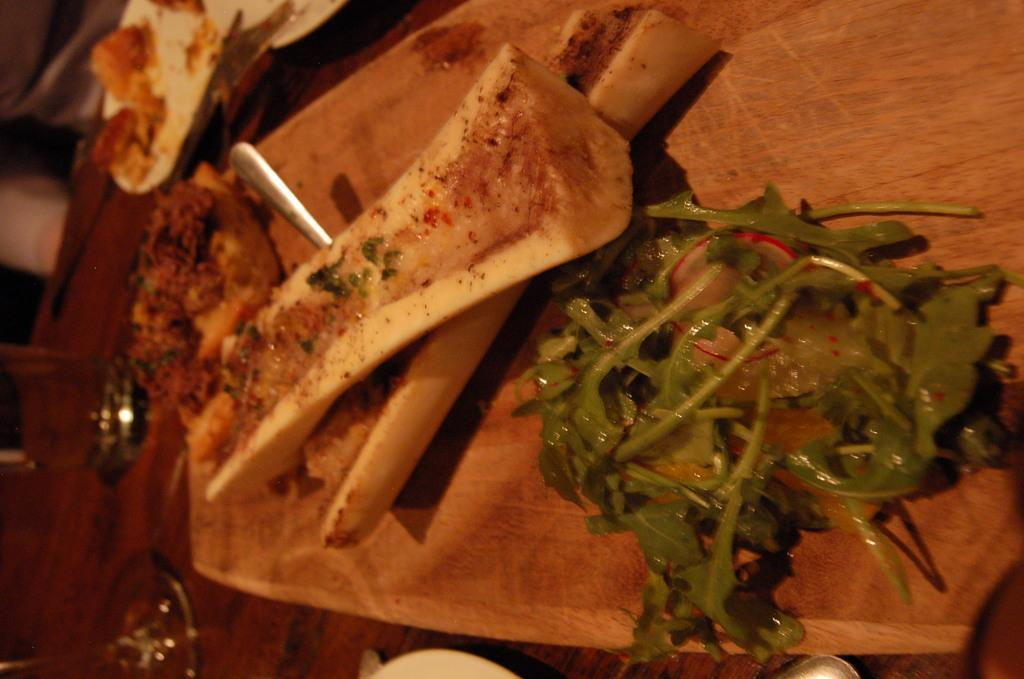What is the surface on which the food items are placed in the image? There is a wooden board on which the food items are placed in the image. What utensil can be seen in the image? There is a spoon in the image. What is another object on which food items are placed in the image? There is a plate on which food items are placed in the image. What type of container is present on the table in the image? There are glasses on the table in the image. What type of wheel is visible in the image? There is no wheel present in the image. Can you describe the actions of the fireman in the image? There is no fireman present in the image. 